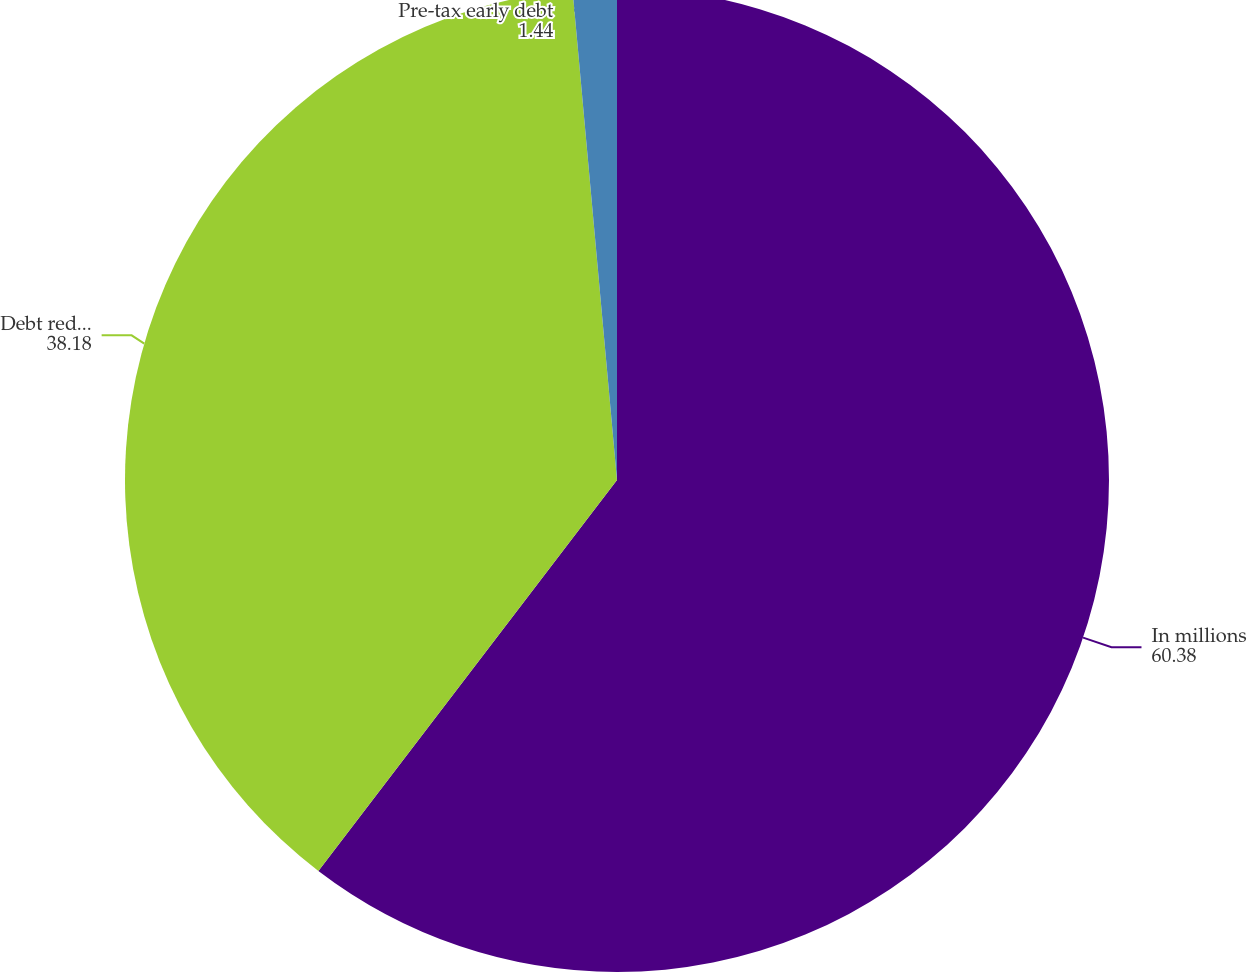Convert chart to OTSL. <chart><loc_0><loc_0><loc_500><loc_500><pie_chart><fcel>In millions<fcel>Debt reductions (a)<fcel>Pre-tax early debt<nl><fcel>60.38%<fcel>38.18%<fcel>1.44%<nl></chart> 